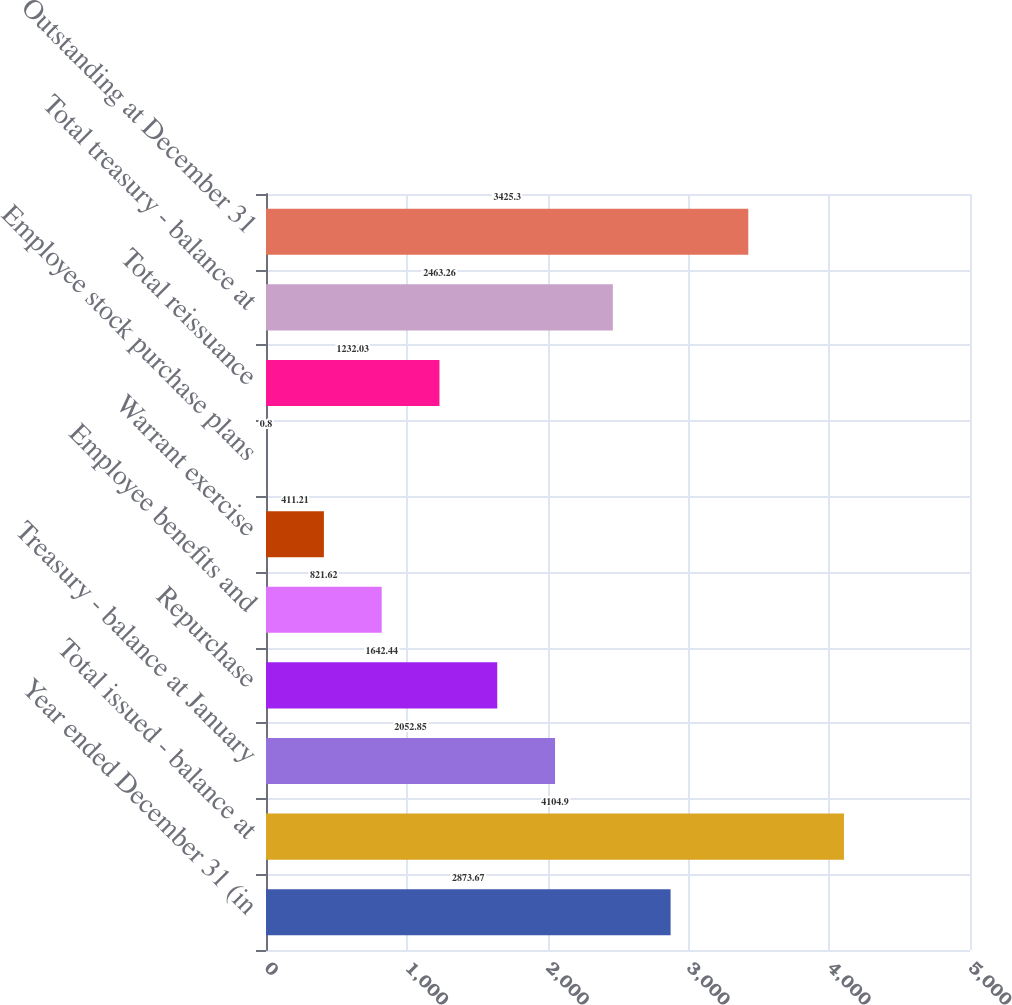Convert chart to OTSL. <chart><loc_0><loc_0><loc_500><loc_500><bar_chart><fcel>Year ended December 31 (in<fcel>Total issued - balance at<fcel>Treasury - balance at January<fcel>Repurchase<fcel>Employee benefits and<fcel>Warrant exercise<fcel>Employee stock purchase plans<fcel>Total reissuance<fcel>Total treasury - balance at<fcel>Outstanding at December 31<nl><fcel>2873.67<fcel>4104.9<fcel>2052.85<fcel>1642.44<fcel>821.62<fcel>411.21<fcel>0.8<fcel>1232.03<fcel>2463.26<fcel>3425.3<nl></chart> 